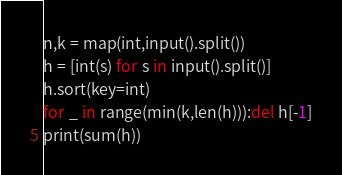Convert code to text. <code><loc_0><loc_0><loc_500><loc_500><_Python_>n,k = map(int,input().split())
h = [int(s) for s in input().split()]
h.sort(key=int)
for _ in range(min(k,len(h))):del h[-1]
print(sum(h))</code> 